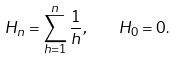Convert formula to latex. <formula><loc_0><loc_0><loc_500><loc_500>H _ { n } = \sum _ { h = 1 } ^ { n } { \frac { 1 } { h } } , \quad H _ { 0 } = 0 .</formula> 